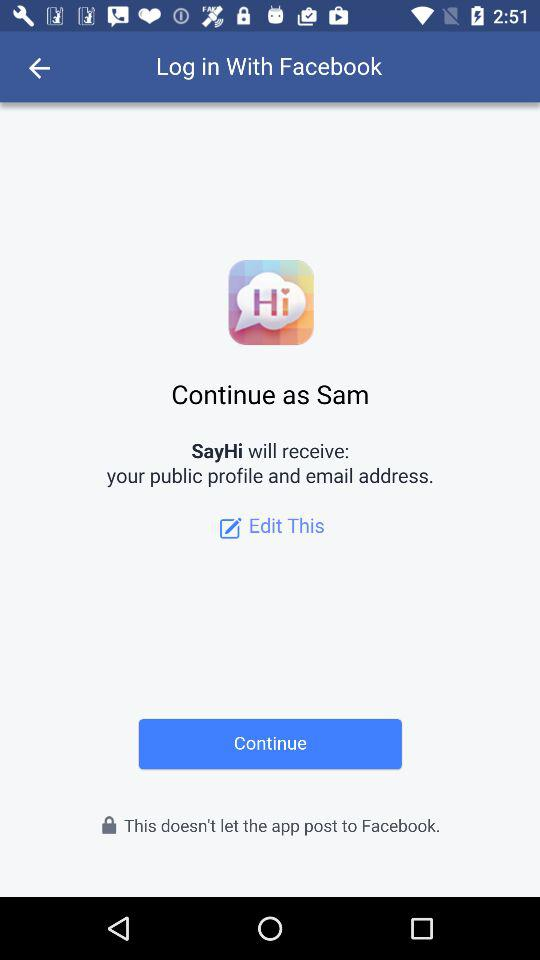What is the user name? The user name is Sam. 